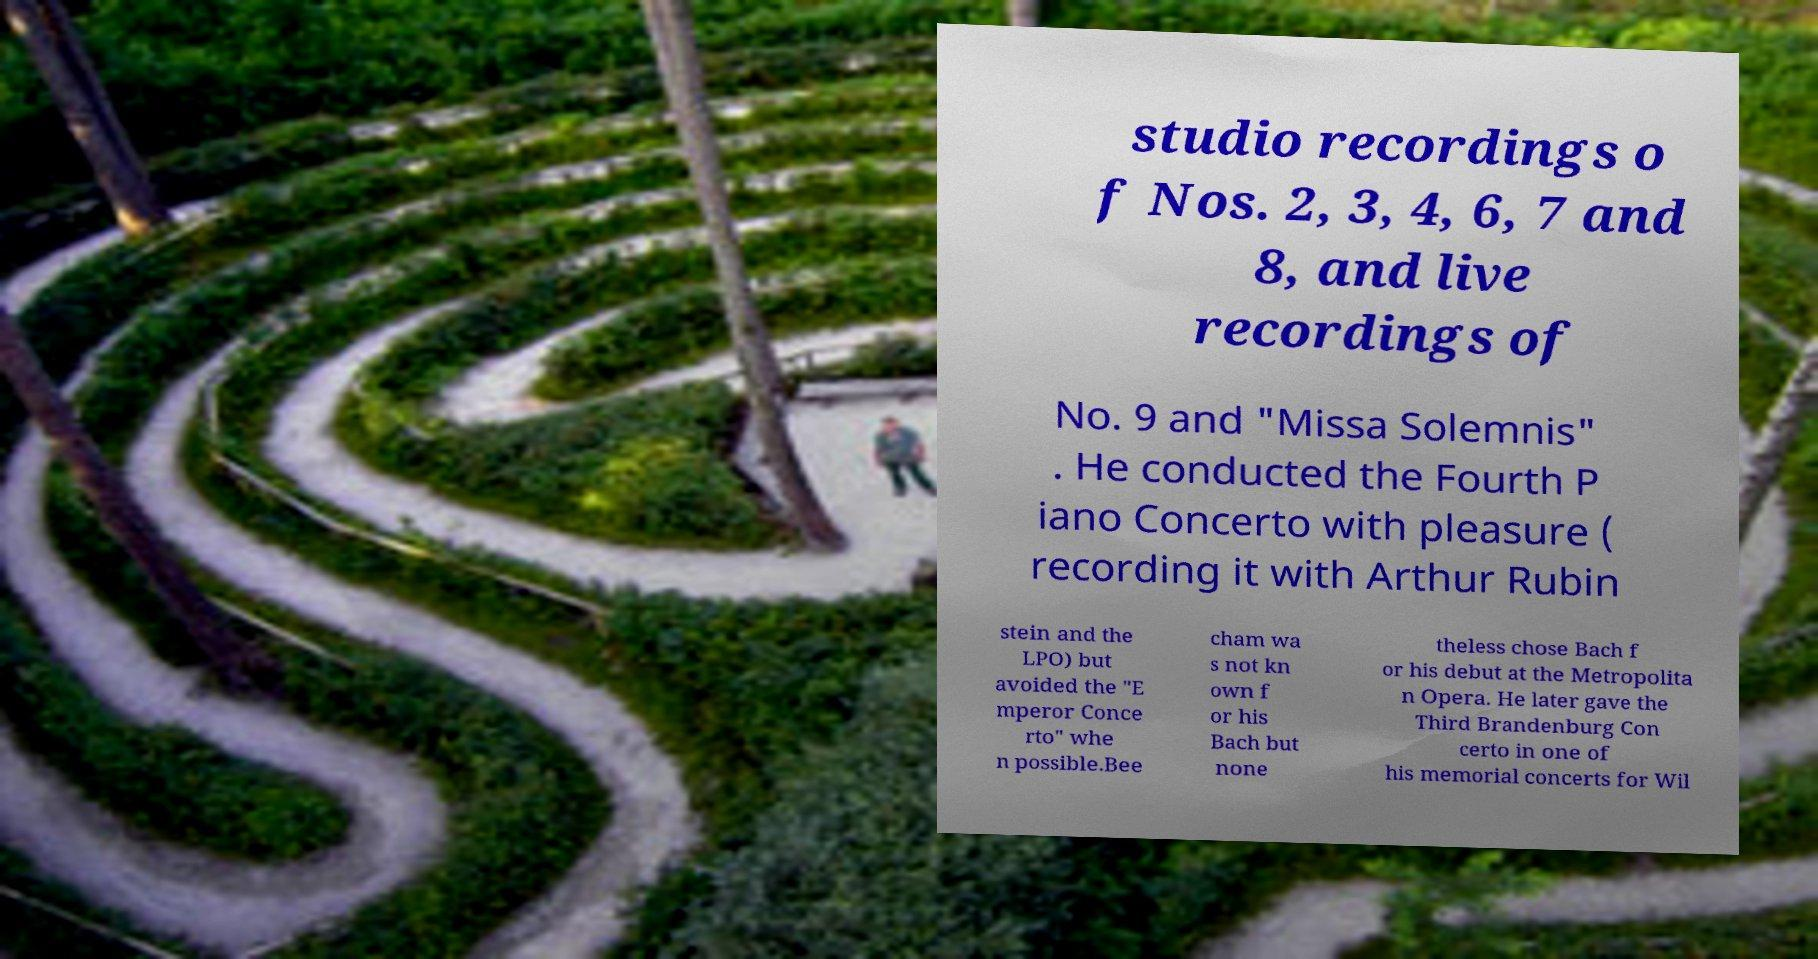What messages or text are displayed in this image? I need them in a readable, typed format. studio recordings o f Nos. 2, 3, 4, 6, 7 and 8, and live recordings of No. 9 and "Missa Solemnis" . He conducted the Fourth P iano Concerto with pleasure ( recording it with Arthur Rubin stein and the LPO) but avoided the "E mperor Conce rto" whe n possible.Bee cham wa s not kn own f or his Bach but none theless chose Bach f or his debut at the Metropolita n Opera. He later gave the Third Brandenburg Con certo in one of his memorial concerts for Wil 